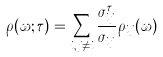<formula> <loc_0><loc_0><loc_500><loc_500>\rho ( \omega ; \tau ) = \sum _ { i , j \ne i } \frac { \sigma _ { i j } ^ { \tau } } { \sigma _ { i j } } \rho _ { i j } ( \omega )</formula> 